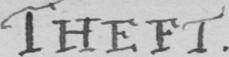What is written in this line of handwriting? THEFT . 